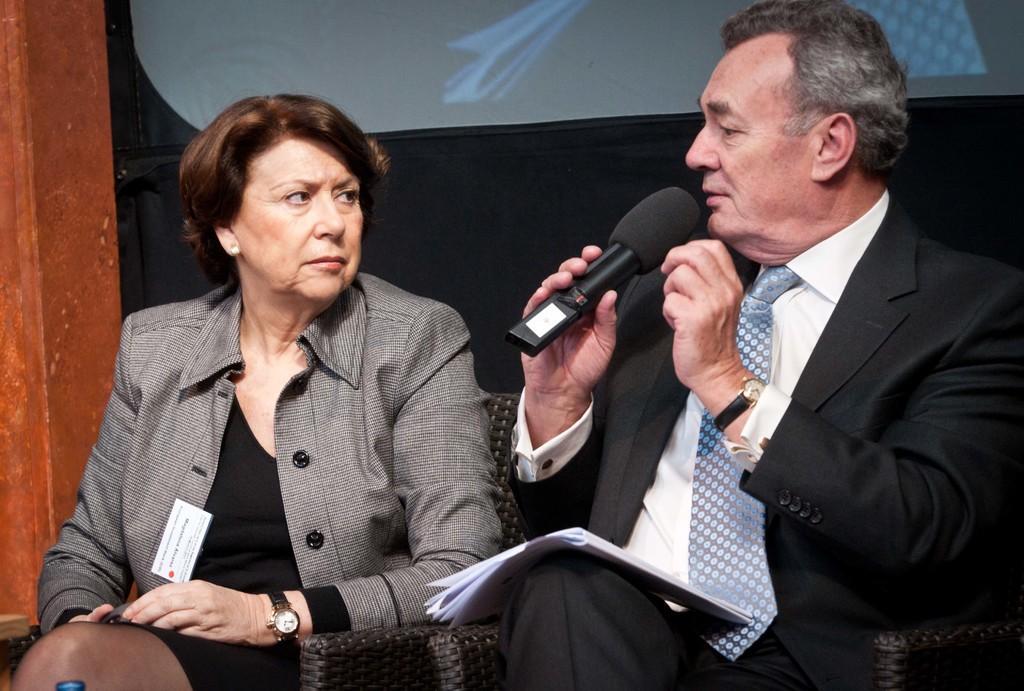Can you describe this image briefly? In this picture we can see a woman and a man sitting on the chairs. He hold a mike with his hand. 